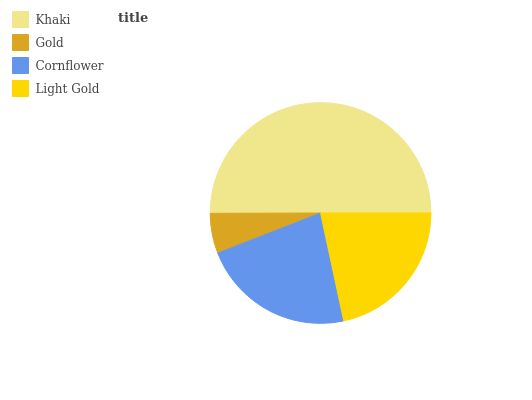Is Gold the minimum?
Answer yes or no. Yes. Is Khaki the maximum?
Answer yes or no. Yes. Is Cornflower the minimum?
Answer yes or no. No. Is Cornflower the maximum?
Answer yes or no. No. Is Cornflower greater than Gold?
Answer yes or no. Yes. Is Gold less than Cornflower?
Answer yes or no. Yes. Is Gold greater than Cornflower?
Answer yes or no. No. Is Cornflower less than Gold?
Answer yes or no. No. Is Cornflower the high median?
Answer yes or no. Yes. Is Light Gold the low median?
Answer yes or no. Yes. Is Khaki the high median?
Answer yes or no. No. Is Cornflower the low median?
Answer yes or no. No. 